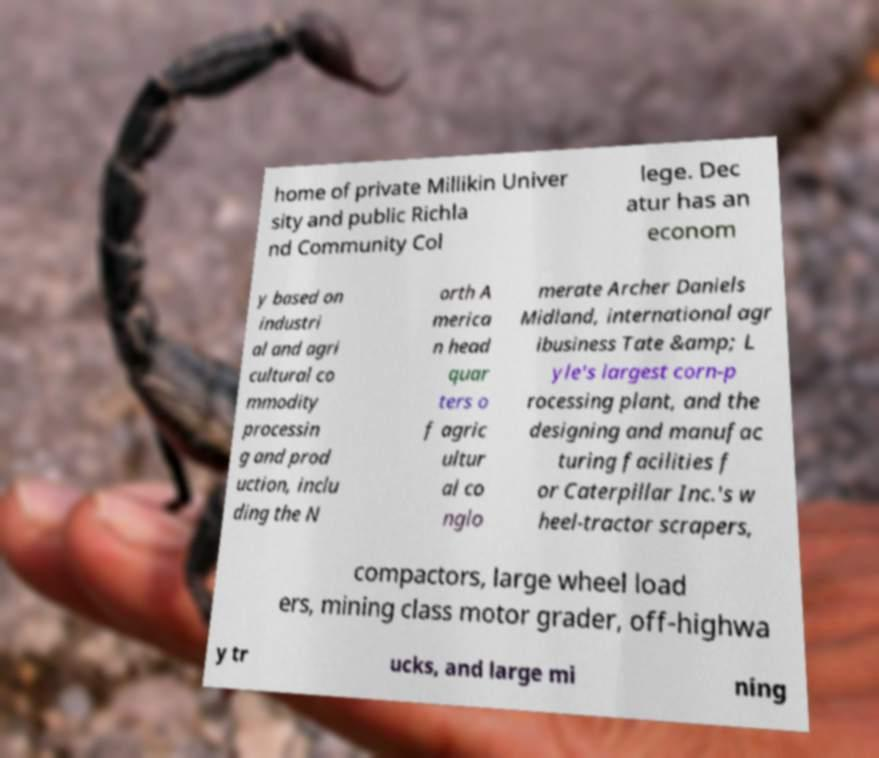Please identify and transcribe the text found in this image. home of private Millikin Univer sity and public Richla nd Community Col lege. Dec atur has an econom y based on industri al and agri cultural co mmodity processin g and prod uction, inclu ding the N orth A merica n head quar ters o f agric ultur al co nglo merate Archer Daniels Midland, international agr ibusiness Tate &amp; L yle's largest corn-p rocessing plant, and the designing and manufac turing facilities f or Caterpillar Inc.'s w heel-tractor scrapers, compactors, large wheel load ers, mining class motor grader, off-highwa y tr ucks, and large mi ning 